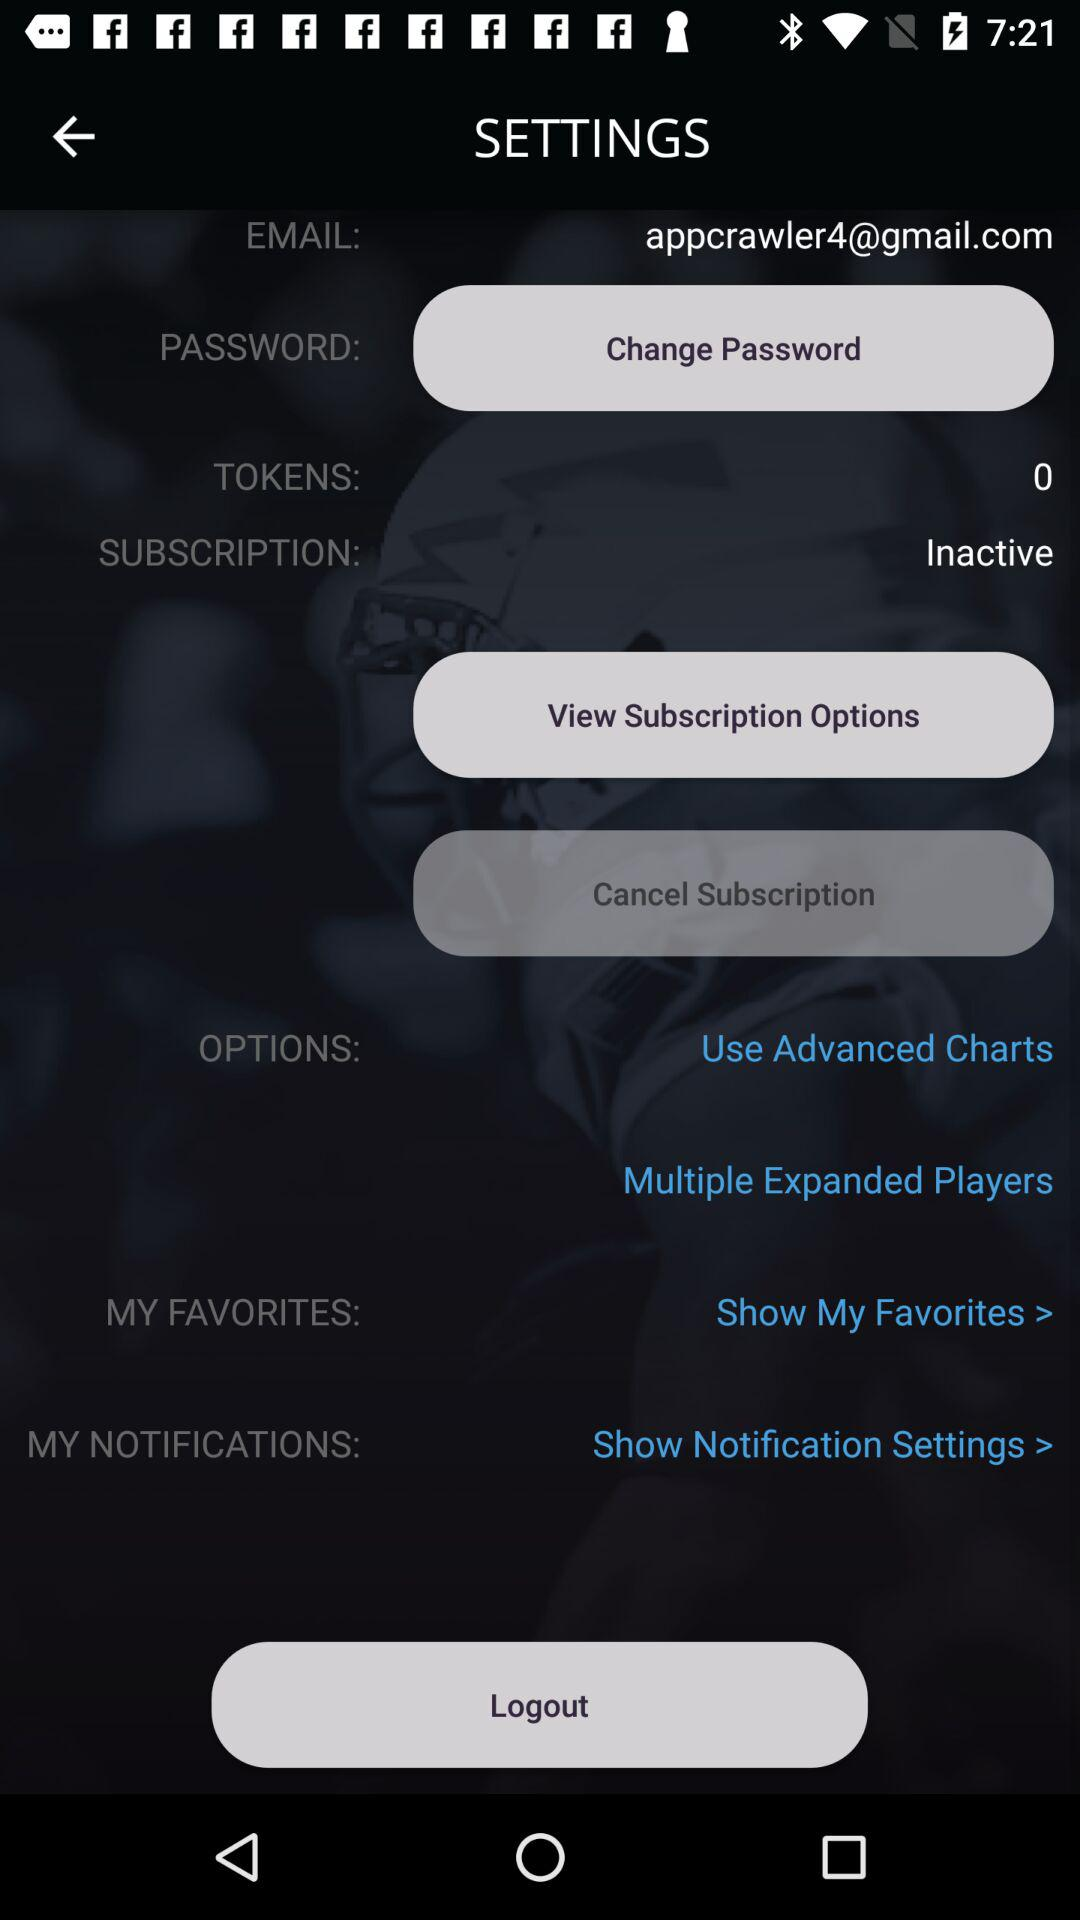What's the status of "SUBSCRIPTION"? The status is "Inactive". 